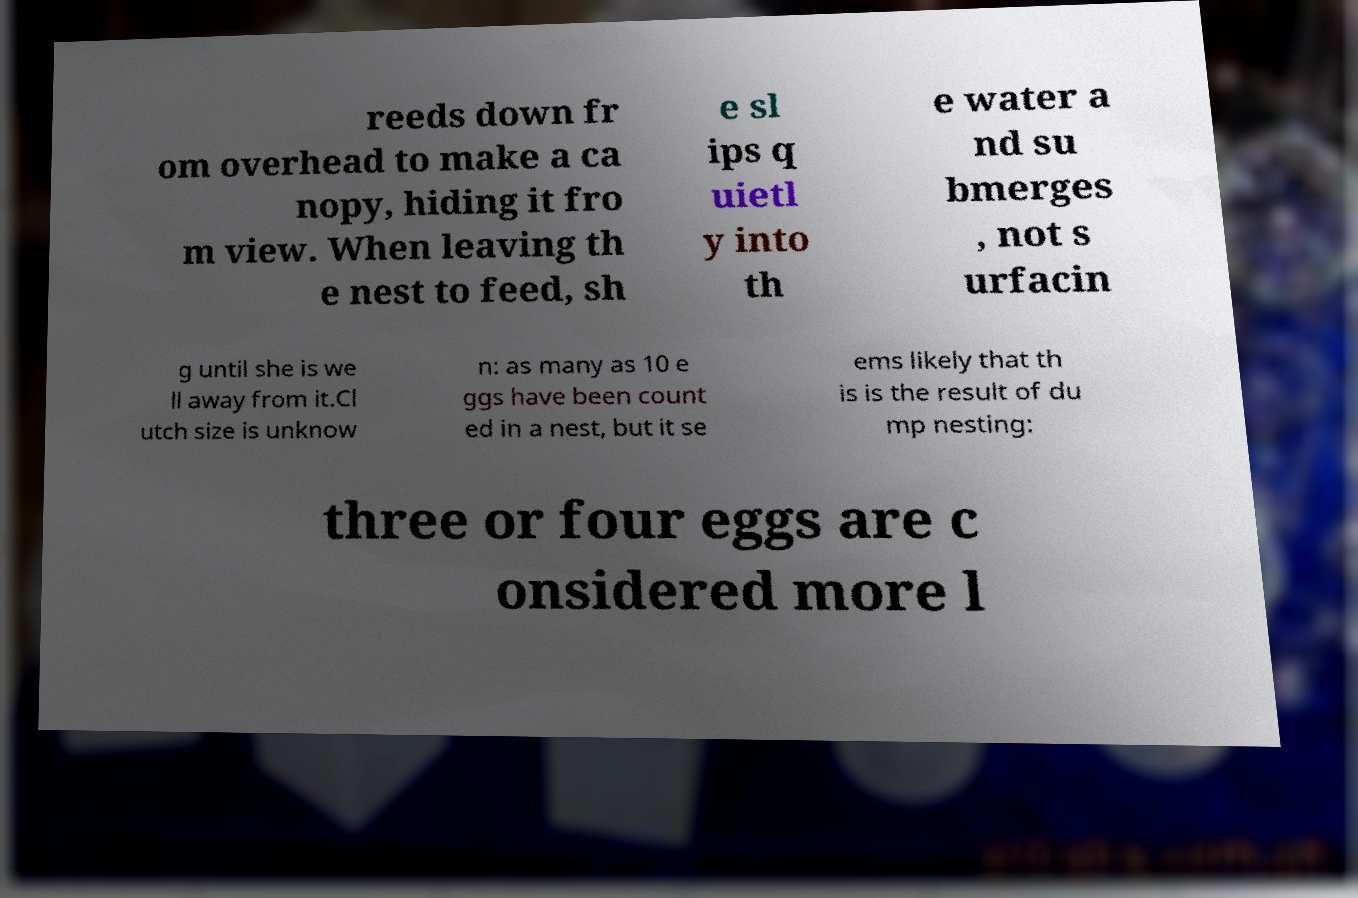For documentation purposes, I need the text within this image transcribed. Could you provide that? reeds down fr om overhead to make a ca nopy, hiding it fro m view. When leaving th e nest to feed, sh e sl ips q uietl y into th e water a nd su bmerges , not s urfacin g until she is we ll away from it.Cl utch size is unknow n: as many as 10 e ggs have been count ed in a nest, but it se ems likely that th is is the result of du mp nesting: three or four eggs are c onsidered more l 